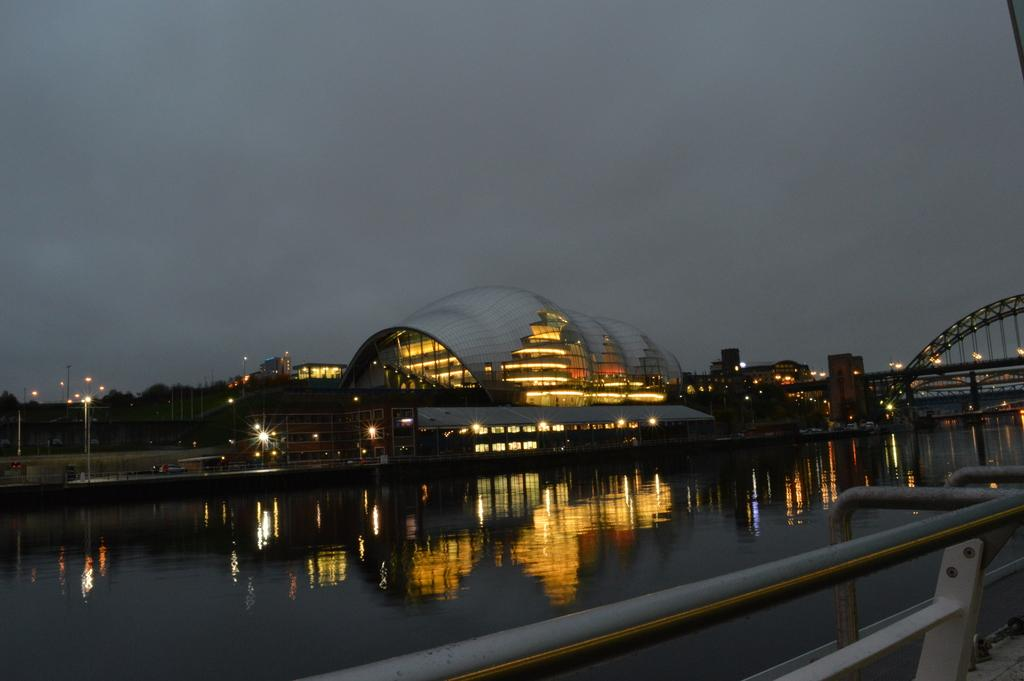What is the main subject of the image? The main subject of the image is a large ship with lights. What is the ship doing in the image? The ship is in the water, and its lights are visible. What else can be seen in the image besides the ship? There is a bridge on the right side of the image, and the sky is visible at the top. How many faces can be seen in the image? There are no faces visible in the image. 